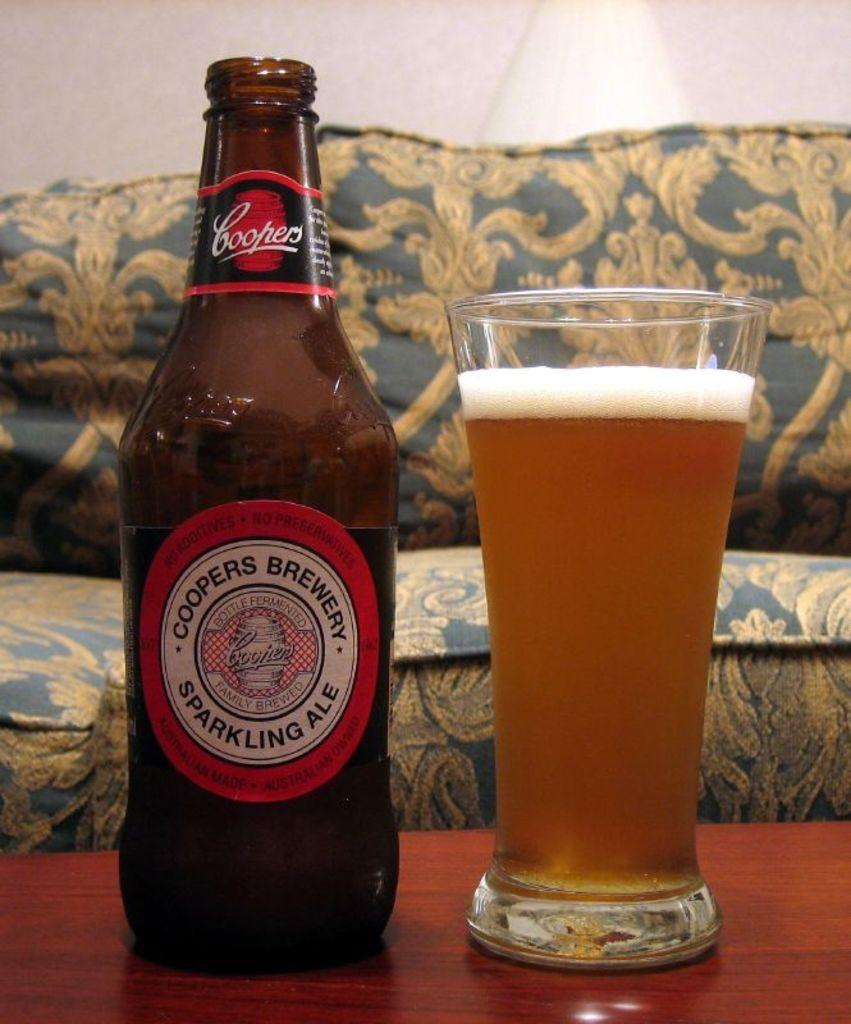Provide a one-sentence caption for the provided image. The beer in the glass in Coopers Sparkling Ale. 